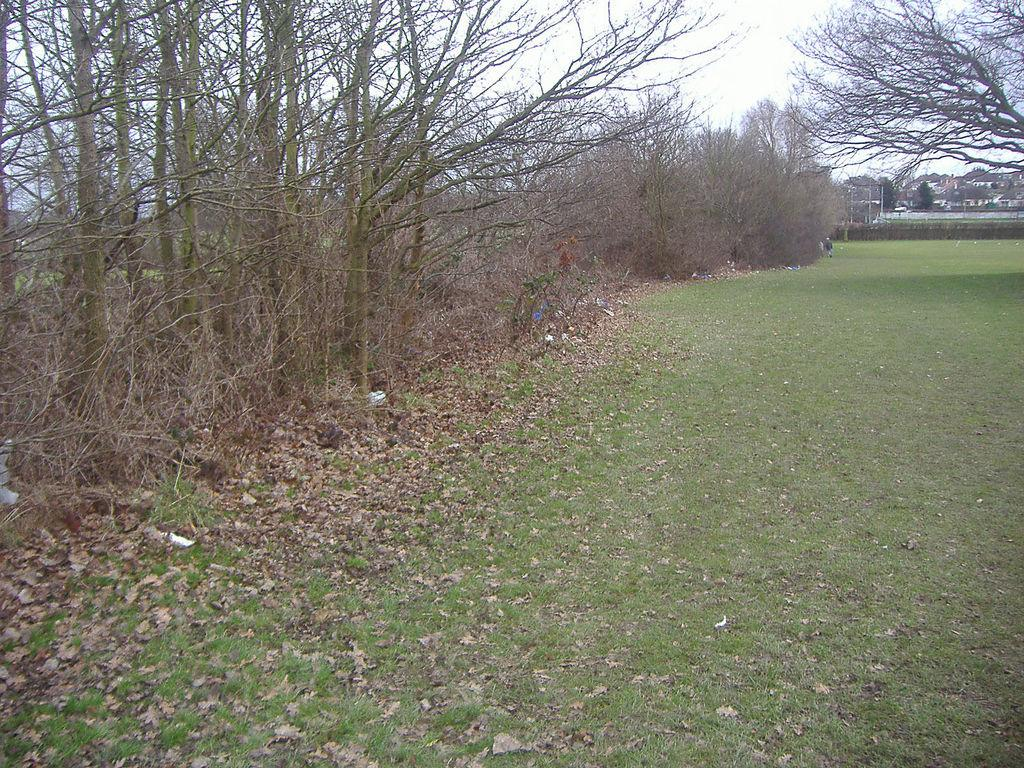What type of vegetation can be seen in the image? There is grass in the image. What else can be found on the ground in the image? Dry leaves are present in the image. What can be seen in the background of the image? There are trees in the image. What is visible in the sky in the image? The sky is visible in the image. What structures are present in the image? There are poles and buildings in the image. What type of book is the secretary reading in the image? There is no book or secretary present in the image. How is the ice being used in the image? There is no ice present in the image. 